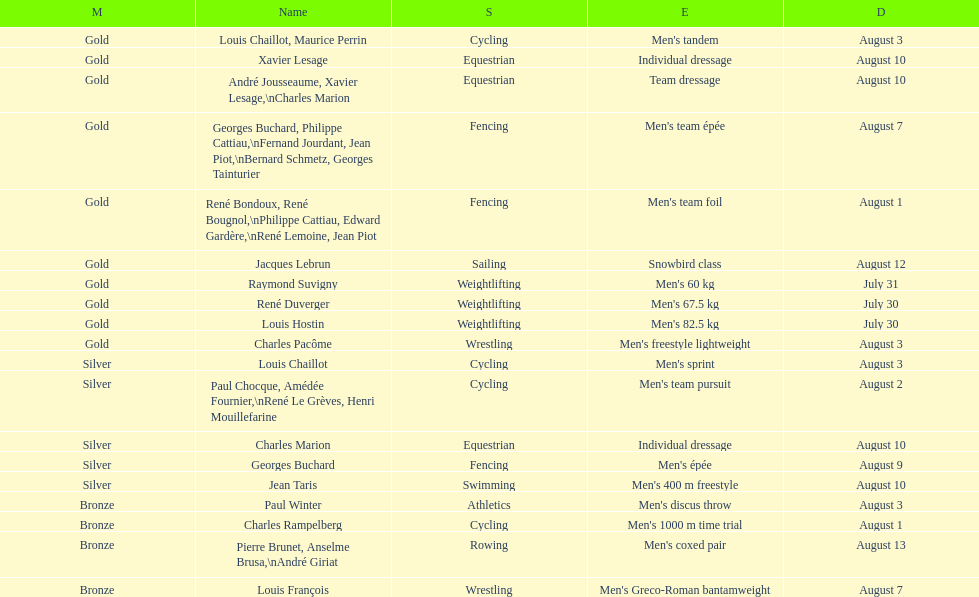How many total gold medals were won by weightlifting? 3. 